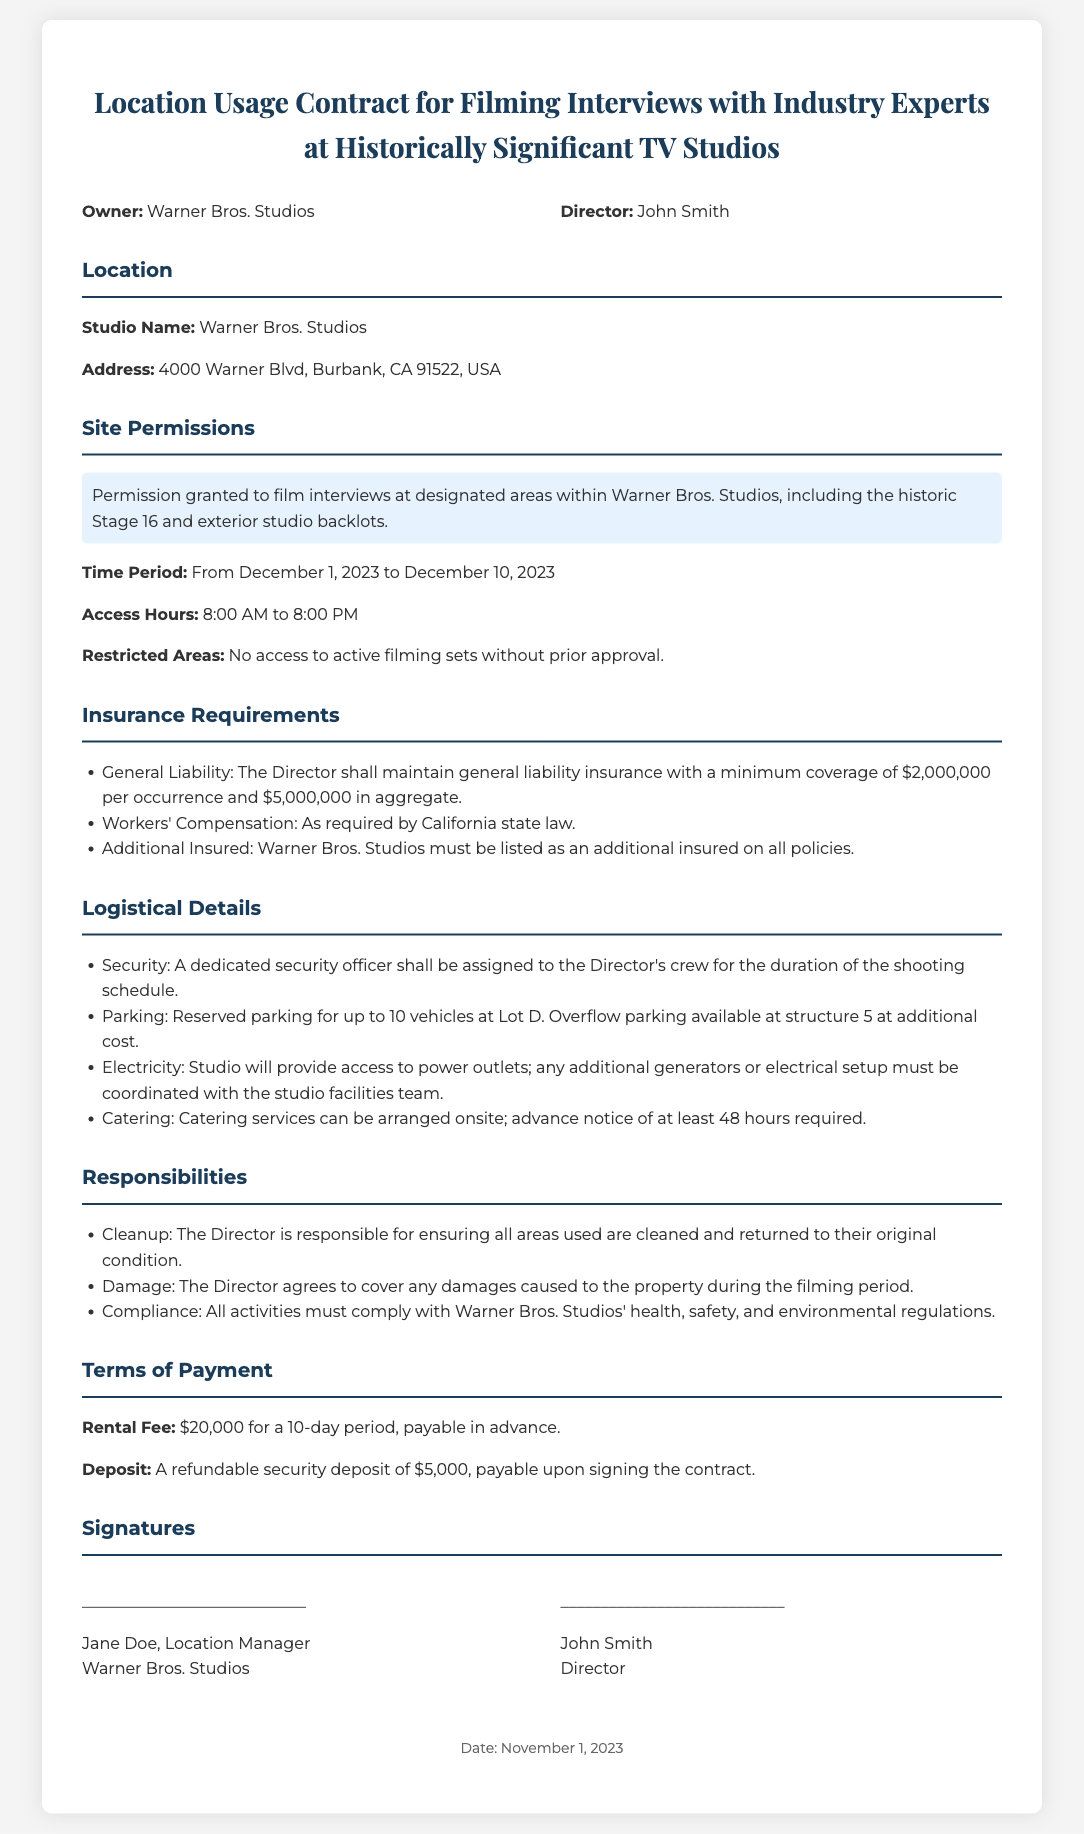What is the name of the studio? The studio name is mentioned in the document under the location section.
Answer: Warner Bros. Studios What is the address of the studio? The address is provided directly in the location section of the document.
Answer: 4000 Warner Blvd, Burbank, CA 91522, USA What is the rental fee for the filming period? The rental fee is specified under the terms of payment section.
Answer: $20,000 What is the duration of access hours? The access hours are stated in the site permissions section.
Answer: 12 hours What insurance coverage is required for general liability? The minimum coverage amount is specified in the insurance requirements section.
Answer: $2,000,000 per occurrence What are the reserved parking details? The parking provisions are found in the logistical details section.
Answer: Reserved parking for up to 10 vehicles at Lot D What is the refundable security deposit amount? The deposit amount is provided in the terms of payment section.
Answer: $5,000 What are the restricted areas for filming? This information is mentioned in the site permissions section of the document.
Answer: No access to active filming sets without prior approval Who is responsible for cleanup after filming? The party responsible for cleanup is specified under responsibilities.
Answer: The Director 